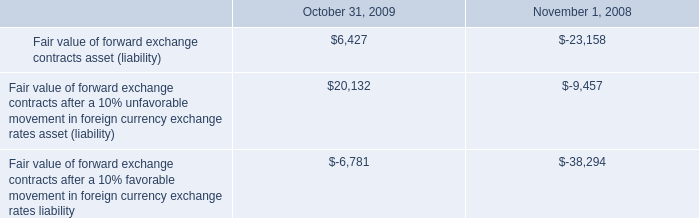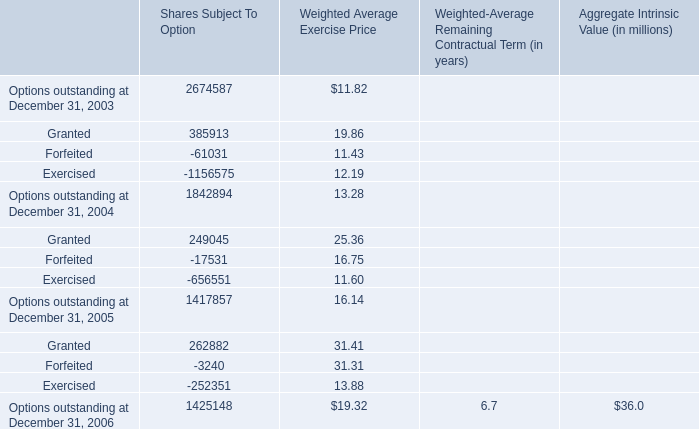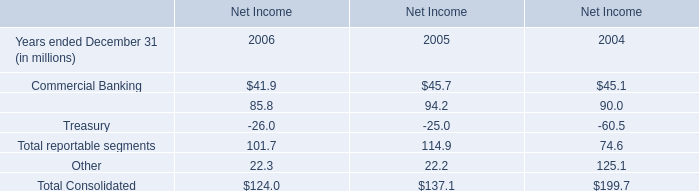what is the the interest expense in 2009? 
Computations: (3.8 / (100 / 100))
Answer: 3.8. Which year is Forfeited for Shares Subject To Option the most? 
Answer: 2005. 